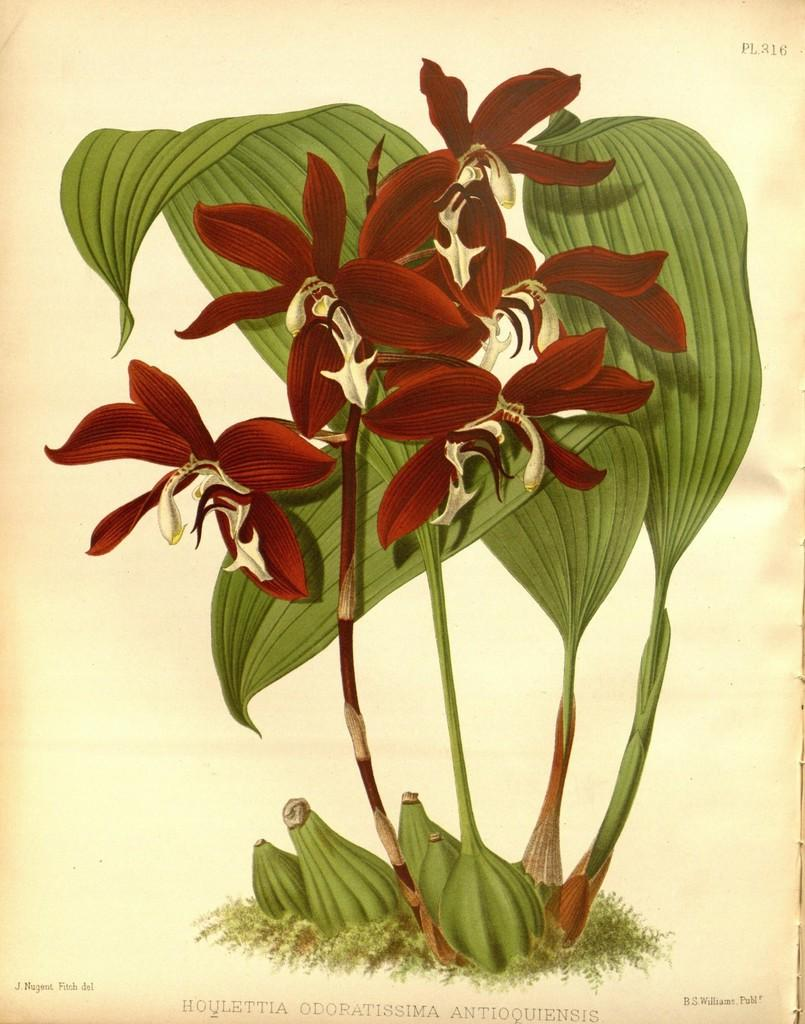What types of images are present on the paper in the image? The images on the paper are pictures of flowers and plants. What is the medium for these images? The images are on a paper. Is there any text accompanying the images? Yes, there is text at the bottom of the paper. How does the light affect the haircut of the flowers in the image? There is no haircut present in the image, as flowers do not have hair. Additionally, the question of how light affects the image is not directly answerable from the provided facts. 